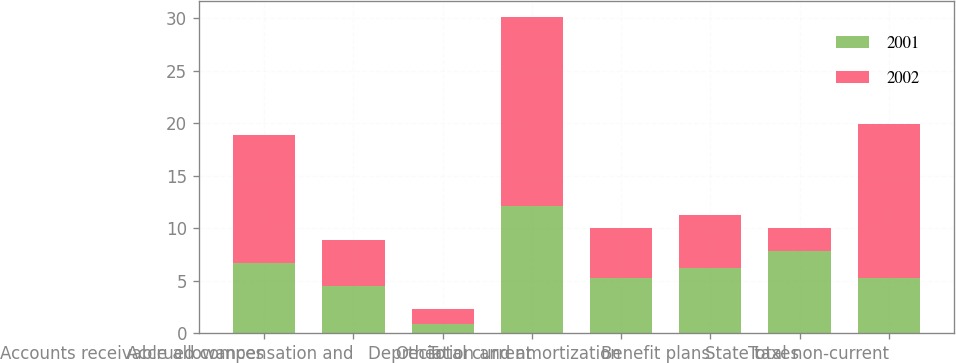<chart> <loc_0><loc_0><loc_500><loc_500><stacked_bar_chart><ecel><fcel>Accounts receivable allowances<fcel>Accrued compensation and<fcel>Other<fcel>Total current<fcel>Depreciation and amortization<fcel>Benefit plans<fcel>State taxes<fcel>Total non-current<nl><fcel>2001<fcel>6.7<fcel>4.5<fcel>0.9<fcel>12.1<fcel>5.3<fcel>6.2<fcel>7.8<fcel>5.3<nl><fcel>2002<fcel>12.2<fcel>4.4<fcel>1.4<fcel>18<fcel>4.7<fcel>5.1<fcel>2.2<fcel>14.6<nl></chart> 